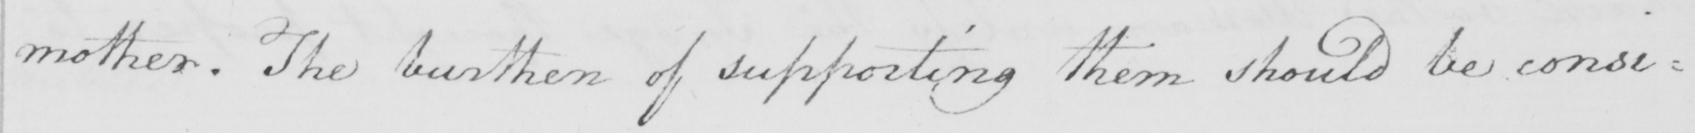What does this handwritten line say? mother . The burthen of supporting them should be consi= 